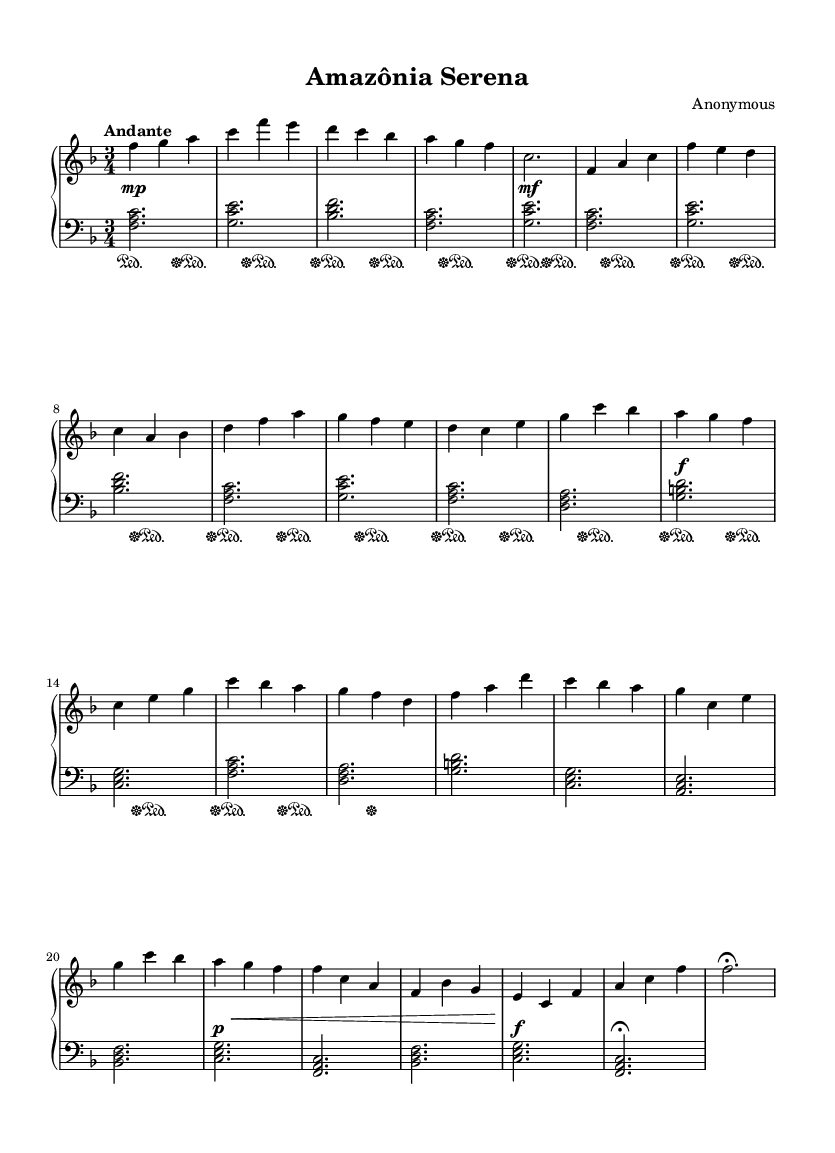What is the key signature of this music? The key signature in the sheet music indicates F major, which has one flat (B flat). This can be observed at the beginning of the staff where the flat symbol appears.
Answer: F major What is the time signature of this piece? The time signature is 3/4, which can be identified by the notation found at the beginning of the music, indicating three beats per measure.
Answer: 3/4 How many sections does the piece have? The music consists of three distinct sections: A, B, and C. This can be inferred from the labeling and different musical material presented in each section.
Answer: Three What is the tempo marking for this piece? The tempo marking indicates "Andante," which refers to a moderately slow tempo, and can be found in the header section of the music.
Answer: Andante What type of dynamics does the piece primarily use? The piece primarily uses a mix of dynamics ranging from piano (soft) to forte (loud), as can be seen by the various dynamic markings throughout the sheet music, indicating the expressive nature of the music typical of the Romantic style.
Answer: Piano to forte Which hand plays the melody in the first section? The right hand plays the melody in the first section. This can be determined by looking at the notes written in the treble clef, which is designated for the right hand.
Answer: Right hand 